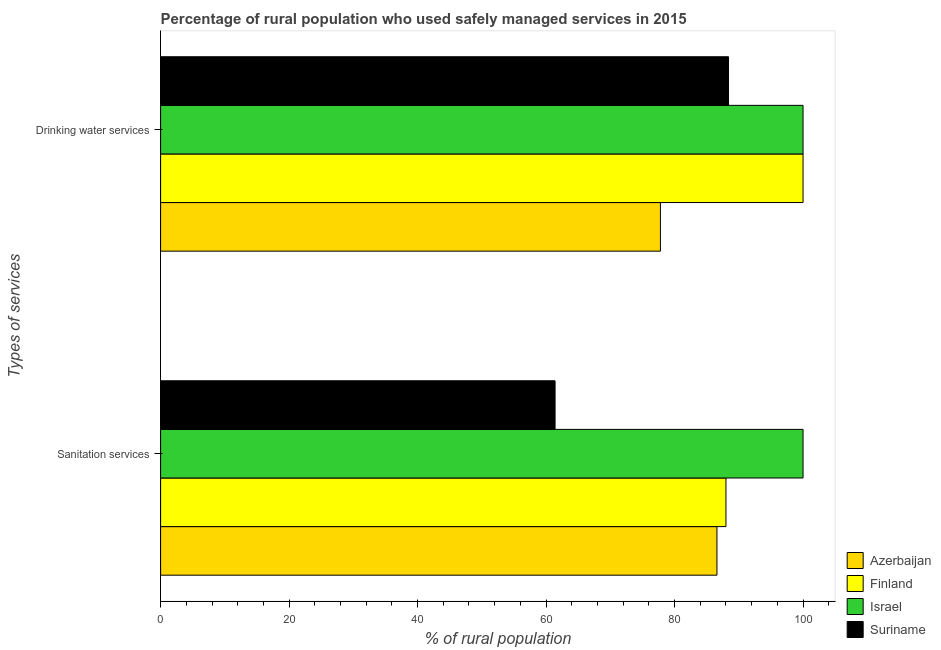How many groups of bars are there?
Your response must be concise. 2. How many bars are there on the 1st tick from the top?
Ensure brevity in your answer.  4. What is the label of the 2nd group of bars from the top?
Make the answer very short. Sanitation services. What is the percentage of rural population who used drinking water services in Israel?
Ensure brevity in your answer.  100. Across all countries, what is the maximum percentage of rural population who used drinking water services?
Your answer should be compact. 100. Across all countries, what is the minimum percentage of rural population who used sanitation services?
Provide a short and direct response. 61.4. In which country was the percentage of rural population who used drinking water services maximum?
Offer a very short reply. Finland. In which country was the percentage of rural population who used sanitation services minimum?
Your response must be concise. Suriname. What is the total percentage of rural population who used sanitation services in the graph?
Provide a succinct answer. 336. What is the difference between the percentage of rural population who used sanitation services in Israel and that in Azerbaijan?
Provide a short and direct response. 13.4. What is the difference between the percentage of rural population who used drinking water services in Suriname and the percentage of rural population who used sanitation services in Finland?
Provide a short and direct response. 0.4. What is the difference between the percentage of rural population who used drinking water services and percentage of rural population who used sanitation services in Suriname?
Your response must be concise. 27. In how many countries, is the percentage of rural population who used sanitation services greater than 60 %?
Ensure brevity in your answer.  4. What is the ratio of the percentage of rural population who used drinking water services in Finland to that in Suriname?
Keep it short and to the point. 1.13. Are all the bars in the graph horizontal?
Your response must be concise. Yes. What is the difference between two consecutive major ticks on the X-axis?
Ensure brevity in your answer.  20. Are the values on the major ticks of X-axis written in scientific E-notation?
Make the answer very short. No. Does the graph contain grids?
Provide a succinct answer. No. How many legend labels are there?
Provide a succinct answer. 4. How are the legend labels stacked?
Provide a succinct answer. Vertical. What is the title of the graph?
Your response must be concise. Percentage of rural population who used safely managed services in 2015. Does "Mexico" appear as one of the legend labels in the graph?
Give a very brief answer. No. What is the label or title of the X-axis?
Keep it short and to the point. % of rural population. What is the label or title of the Y-axis?
Provide a succinct answer. Types of services. What is the % of rural population of Azerbaijan in Sanitation services?
Your response must be concise. 86.6. What is the % of rural population of Israel in Sanitation services?
Offer a very short reply. 100. What is the % of rural population in Suriname in Sanitation services?
Keep it short and to the point. 61.4. What is the % of rural population in Azerbaijan in Drinking water services?
Provide a short and direct response. 77.8. What is the % of rural population in Finland in Drinking water services?
Provide a succinct answer. 100. What is the % of rural population of Suriname in Drinking water services?
Make the answer very short. 88.4. Across all Types of services, what is the maximum % of rural population of Azerbaijan?
Ensure brevity in your answer.  86.6. Across all Types of services, what is the maximum % of rural population of Finland?
Offer a very short reply. 100. Across all Types of services, what is the maximum % of rural population of Israel?
Offer a very short reply. 100. Across all Types of services, what is the maximum % of rural population in Suriname?
Offer a terse response. 88.4. Across all Types of services, what is the minimum % of rural population in Azerbaijan?
Provide a short and direct response. 77.8. Across all Types of services, what is the minimum % of rural population of Suriname?
Offer a very short reply. 61.4. What is the total % of rural population in Azerbaijan in the graph?
Provide a short and direct response. 164.4. What is the total % of rural population of Finland in the graph?
Your response must be concise. 188. What is the total % of rural population of Israel in the graph?
Provide a short and direct response. 200. What is the total % of rural population in Suriname in the graph?
Your response must be concise. 149.8. What is the difference between the % of rural population in Azerbaijan in Sanitation services and that in Drinking water services?
Provide a succinct answer. 8.8. What is the difference between the % of rural population of Finland in Sanitation services and that in Drinking water services?
Your answer should be very brief. -12. What is the difference between the % of rural population in Israel in Sanitation services and that in Drinking water services?
Give a very brief answer. 0. What is the difference between the % of rural population of Azerbaijan in Sanitation services and the % of rural population of Suriname in Drinking water services?
Your answer should be very brief. -1.8. What is the difference between the % of rural population of Finland in Sanitation services and the % of rural population of Israel in Drinking water services?
Provide a short and direct response. -12. What is the difference between the % of rural population of Finland in Sanitation services and the % of rural population of Suriname in Drinking water services?
Give a very brief answer. -0.4. What is the difference between the % of rural population of Israel in Sanitation services and the % of rural population of Suriname in Drinking water services?
Your answer should be very brief. 11.6. What is the average % of rural population of Azerbaijan per Types of services?
Your response must be concise. 82.2. What is the average % of rural population in Finland per Types of services?
Keep it short and to the point. 94. What is the average % of rural population in Israel per Types of services?
Offer a very short reply. 100. What is the average % of rural population in Suriname per Types of services?
Offer a terse response. 74.9. What is the difference between the % of rural population in Azerbaijan and % of rural population in Suriname in Sanitation services?
Your answer should be compact. 25.2. What is the difference between the % of rural population in Finland and % of rural population in Israel in Sanitation services?
Give a very brief answer. -12. What is the difference between the % of rural population of Finland and % of rural population of Suriname in Sanitation services?
Your answer should be very brief. 26.6. What is the difference between the % of rural population of Israel and % of rural population of Suriname in Sanitation services?
Offer a very short reply. 38.6. What is the difference between the % of rural population in Azerbaijan and % of rural population in Finland in Drinking water services?
Provide a short and direct response. -22.2. What is the difference between the % of rural population in Azerbaijan and % of rural population in Israel in Drinking water services?
Your answer should be compact. -22.2. What is the difference between the % of rural population of Azerbaijan and % of rural population of Suriname in Drinking water services?
Your response must be concise. -10.6. What is the difference between the % of rural population in Finland and % of rural population in Israel in Drinking water services?
Your response must be concise. 0. What is the difference between the % of rural population of Finland and % of rural population of Suriname in Drinking water services?
Ensure brevity in your answer.  11.6. What is the difference between the % of rural population of Israel and % of rural population of Suriname in Drinking water services?
Your answer should be compact. 11.6. What is the ratio of the % of rural population in Azerbaijan in Sanitation services to that in Drinking water services?
Your answer should be compact. 1.11. What is the ratio of the % of rural population in Finland in Sanitation services to that in Drinking water services?
Provide a short and direct response. 0.88. What is the ratio of the % of rural population in Israel in Sanitation services to that in Drinking water services?
Keep it short and to the point. 1. What is the ratio of the % of rural population in Suriname in Sanitation services to that in Drinking water services?
Your response must be concise. 0.69. What is the difference between the highest and the second highest % of rural population of Azerbaijan?
Offer a very short reply. 8.8. What is the difference between the highest and the second highest % of rural population in Israel?
Your answer should be compact. 0. What is the difference between the highest and the lowest % of rural population in Suriname?
Give a very brief answer. 27. 